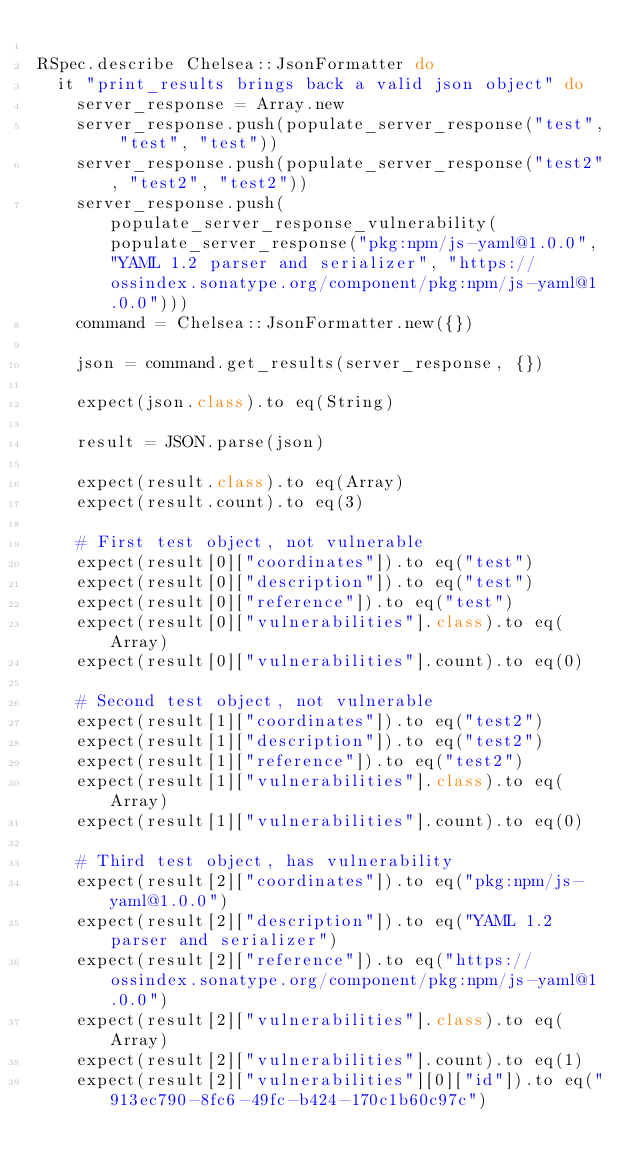<code> <loc_0><loc_0><loc_500><loc_500><_Ruby_>
RSpec.describe Chelsea::JsonFormatter do
  it "print_results brings back a valid json object" do
    server_response = Array.new
    server_response.push(populate_server_response("test", "test", "test")) 
    server_response.push(populate_server_response("test2", "test2", "test2"))
    server_response.push(populate_server_response_vulnerability(populate_server_response("pkg:npm/js-yaml@1.0.0", "YAML 1.2 parser and serializer", "https://ossindex.sonatype.org/component/pkg:npm/js-yaml@1.0.0")))
    command = Chelsea::JsonFormatter.new({})

    json = command.get_results(server_response, {})

    expect(json.class).to eq(String)

    result = JSON.parse(json)

    expect(result.class).to eq(Array)
    expect(result.count).to eq(3)

    # First test object, not vulnerable
    expect(result[0]["coordinates"]).to eq("test")
    expect(result[0]["description"]).to eq("test")
    expect(result[0]["reference"]).to eq("test")
    expect(result[0]["vulnerabilities"].class).to eq(Array)
    expect(result[0]["vulnerabilities"].count).to eq(0)

    # Second test object, not vulnerable
    expect(result[1]["coordinates"]).to eq("test2")
    expect(result[1]["description"]).to eq("test2")
    expect(result[1]["reference"]).to eq("test2")
    expect(result[1]["vulnerabilities"].class).to eq(Array)
    expect(result[1]["vulnerabilities"].count).to eq(0)

    # Third test object, has vulnerability
    expect(result[2]["coordinates"]).to eq("pkg:npm/js-yaml@1.0.0")
    expect(result[2]["description"]).to eq("YAML 1.2 parser and serializer")
    expect(result[2]["reference"]).to eq("https://ossindex.sonatype.org/component/pkg:npm/js-yaml@1.0.0")
    expect(result[2]["vulnerabilities"].class).to eq(Array)
    expect(result[2]["vulnerabilities"].count).to eq(1)
    expect(result[2]["vulnerabilities"][0]["id"]).to eq("913ec790-8fc6-49fc-b424-170c1b60c97c")</code> 